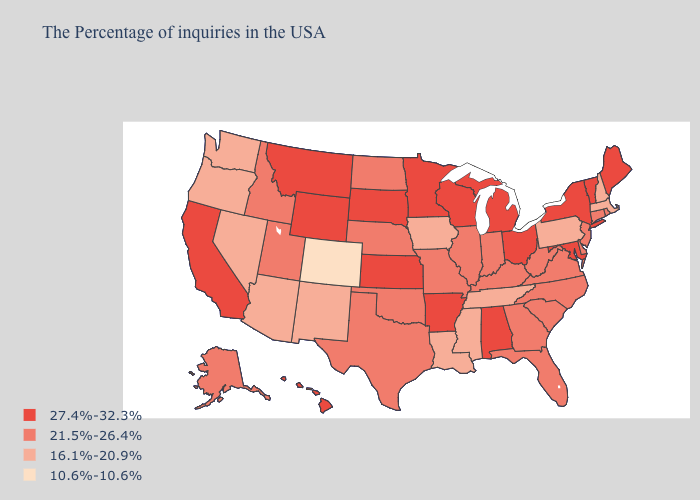Does West Virginia have the lowest value in the South?
Write a very short answer. No. What is the value of Louisiana?
Answer briefly. 16.1%-20.9%. Does Wyoming have the highest value in the West?
Short answer required. Yes. What is the highest value in the USA?
Quick response, please. 27.4%-32.3%. Does Colorado have the lowest value in the USA?
Keep it brief. Yes. Name the states that have a value in the range 10.6%-10.6%?
Be succinct. Colorado. Name the states that have a value in the range 21.5%-26.4%?
Answer briefly. Rhode Island, Connecticut, New Jersey, Delaware, Virginia, North Carolina, South Carolina, West Virginia, Florida, Georgia, Kentucky, Indiana, Illinois, Missouri, Nebraska, Oklahoma, Texas, North Dakota, Utah, Idaho, Alaska. What is the value of Utah?
Write a very short answer. 21.5%-26.4%. What is the lowest value in states that border Wyoming?
Write a very short answer. 10.6%-10.6%. Does Pennsylvania have a lower value than Oklahoma?
Quick response, please. Yes. What is the highest value in states that border Kansas?
Be succinct. 21.5%-26.4%. What is the lowest value in the USA?
Write a very short answer. 10.6%-10.6%. Does Montana have the highest value in the West?
Answer briefly. Yes. Name the states that have a value in the range 27.4%-32.3%?
Write a very short answer. Maine, Vermont, New York, Maryland, Ohio, Michigan, Alabama, Wisconsin, Arkansas, Minnesota, Kansas, South Dakota, Wyoming, Montana, California, Hawaii. Does the first symbol in the legend represent the smallest category?
Concise answer only. No. 